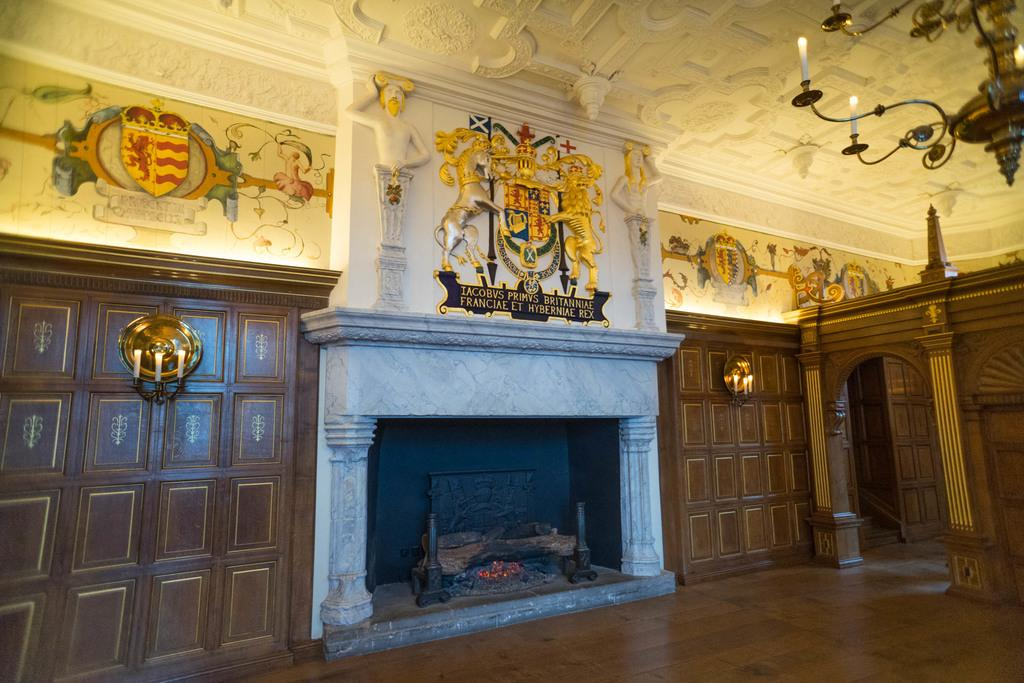What color are the doors in the image? The doors in the image are brown. What is located in front of the doors? There is a fireplace in front of the doors. What can be seen in the background of the image? There are statues and candles in the background of the image. What color is the wall in the background? The wall in the background is white. How many balloons are floating in the fireplace in the image? There are no balloons present in the image, and therefore none are floating in the fireplace. Is there a body of water visible in the image? There is no body of water visible in the image. 